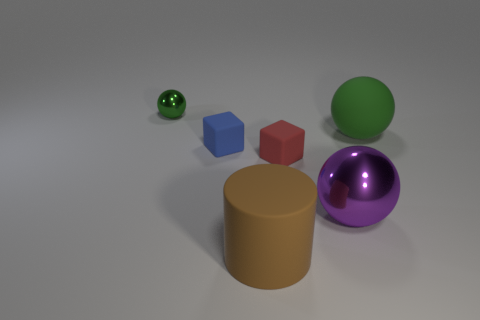There is a green sphere to the right of the shiny ball in front of the large green matte thing; what size is it?
Make the answer very short. Large. How many small things are either blue blocks or green balls?
Provide a short and direct response. 2. There is a sphere behind the object on the right side of the metallic sphere that is in front of the small metallic object; what is its size?
Your answer should be compact. Small. Is there any other thing that is the same color as the large cylinder?
Make the answer very short. No. The sphere that is on the left side of the metallic object in front of the shiny object that is behind the large shiny sphere is made of what material?
Provide a succinct answer. Metal. Is the big green rubber object the same shape as the brown rubber object?
Your answer should be compact. No. Are there any other things that have the same material as the tiny green ball?
Give a very brief answer. Yes. How many things are both left of the big brown rubber thing and in front of the small green metallic ball?
Make the answer very short. 1. There is a small matte object to the left of the large rubber thing in front of the big green ball; what color is it?
Offer a very short reply. Blue. Are there an equal number of cubes behind the large green ball and blue rubber things?
Your response must be concise. No. 